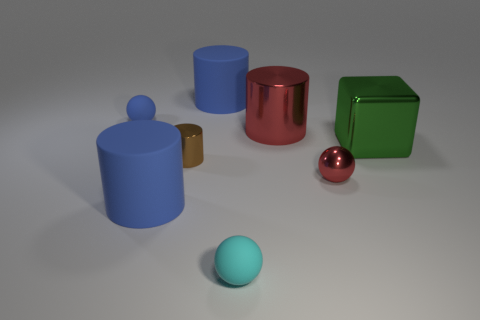Add 2 tiny purple matte balls. How many objects exist? 10 Subtract all spheres. How many objects are left? 5 Subtract all tiny cyan balls. Subtract all tiny brown shiny things. How many objects are left? 6 Add 3 blocks. How many blocks are left? 4 Add 3 small cyan blocks. How many small cyan blocks exist? 3 Subtract 0 yellow cylinders. How many objects are left? 8 